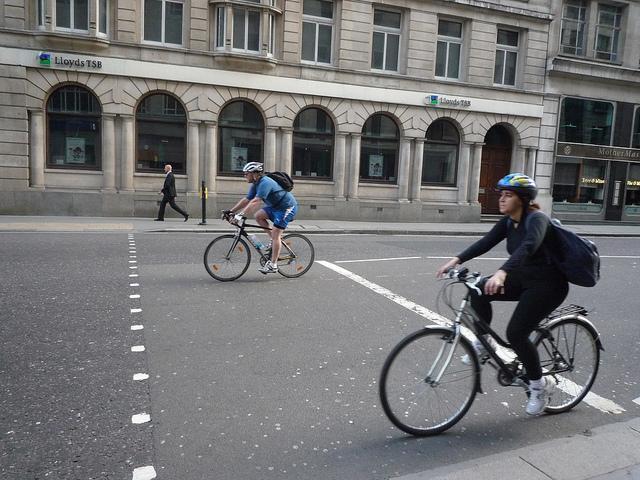When did two companies merge into this one bank?
Make your selection from the four choices given to correctly answer the question.
Options: 2018, 1981, 2008, 1995. 1995. 